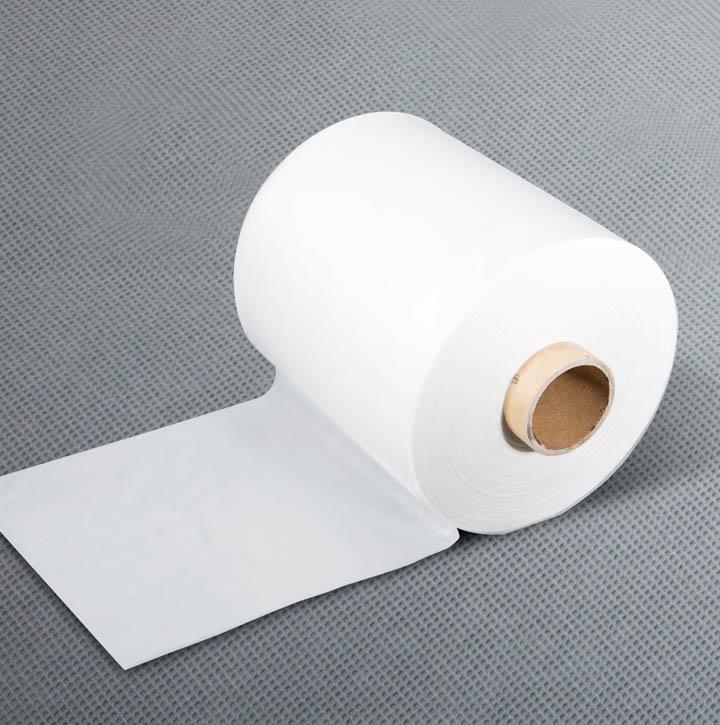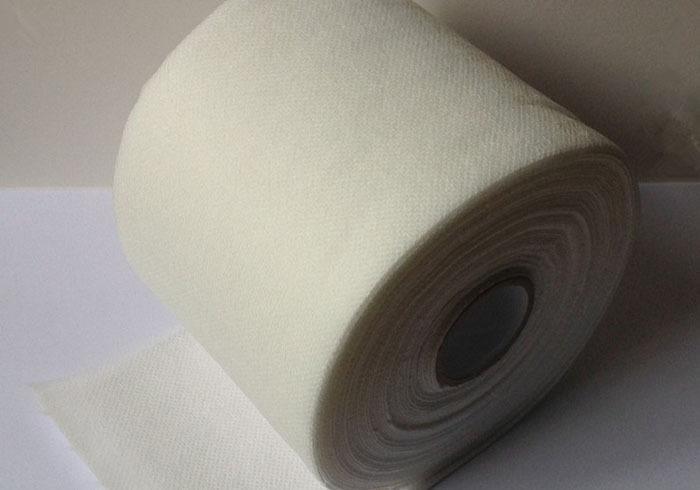The first image is the image on the left, the second image is the image on the right. Evaluate the accuracy of this statement regarding the images: "There is toilet paper with a little bit unrolled underneath on the ground.". Is it true? Answer yes or no. Yes. 